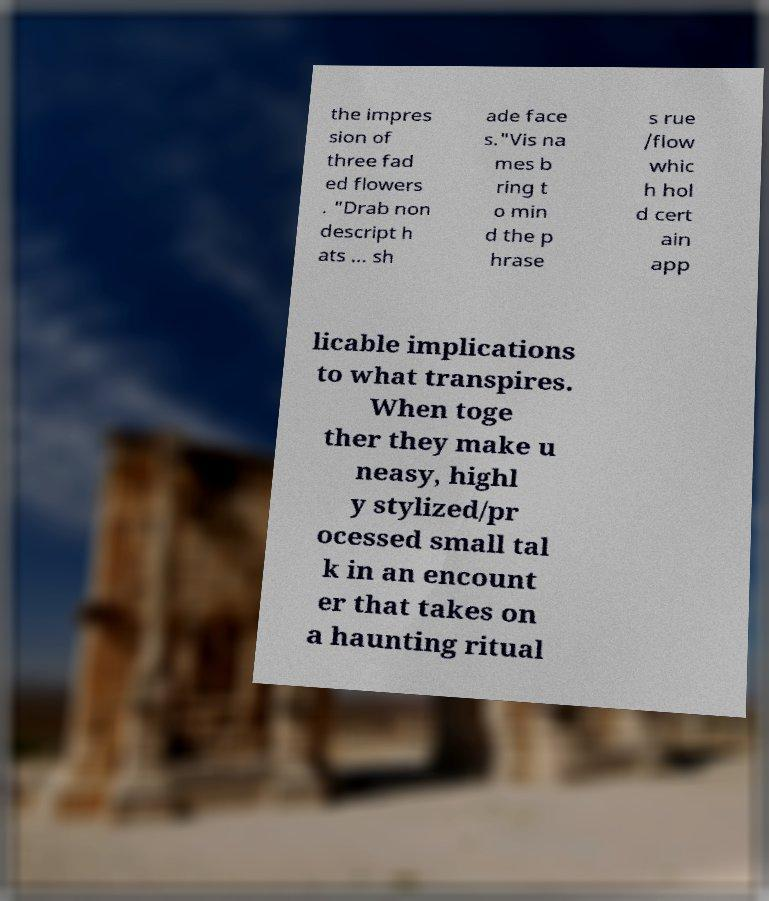There's text embedded in this image that I need extracted. Can you transcribe it verbatim? the impres sion of three fad ed flowers . "Drab non descript h ats … sh ade face s."Vis na mes b ring t o min d the p hrase s rue /flow whic h hol d cert ain app licable implications to what transpires. When toge ther they make u neasy, highl y stylized/pr ocessed small tal k in an encount er that takes on a haunting ritual 